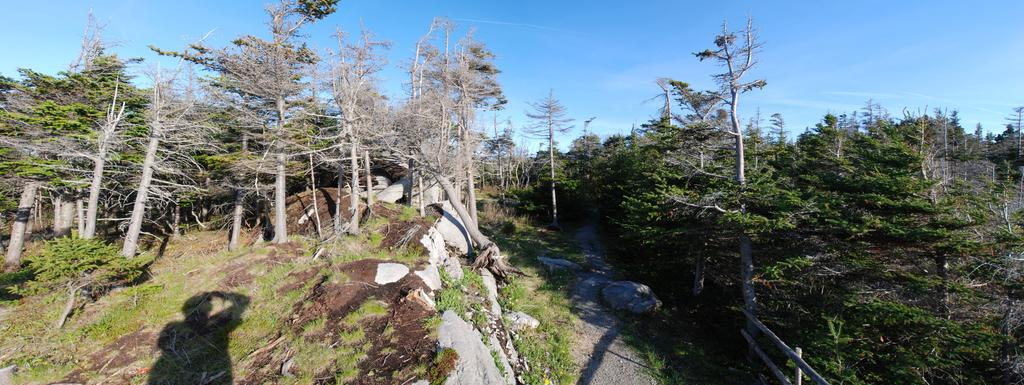What type of trees can be seen in the image? There are dried trees and green trees in the image. What is visible in the background of the image? The sky is visible in the image. What colors are present in the sky? The sky has blue and white colors. What type of head can be seen on the bike in the image? There is no bike present in the image, so there is no head to be seen on a bike. 